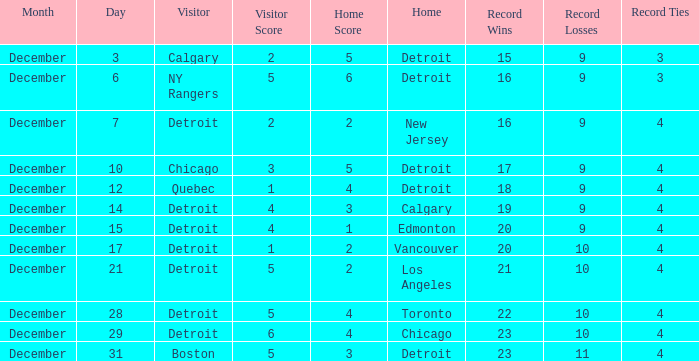Who is the visitor on december 3? Calgary. 